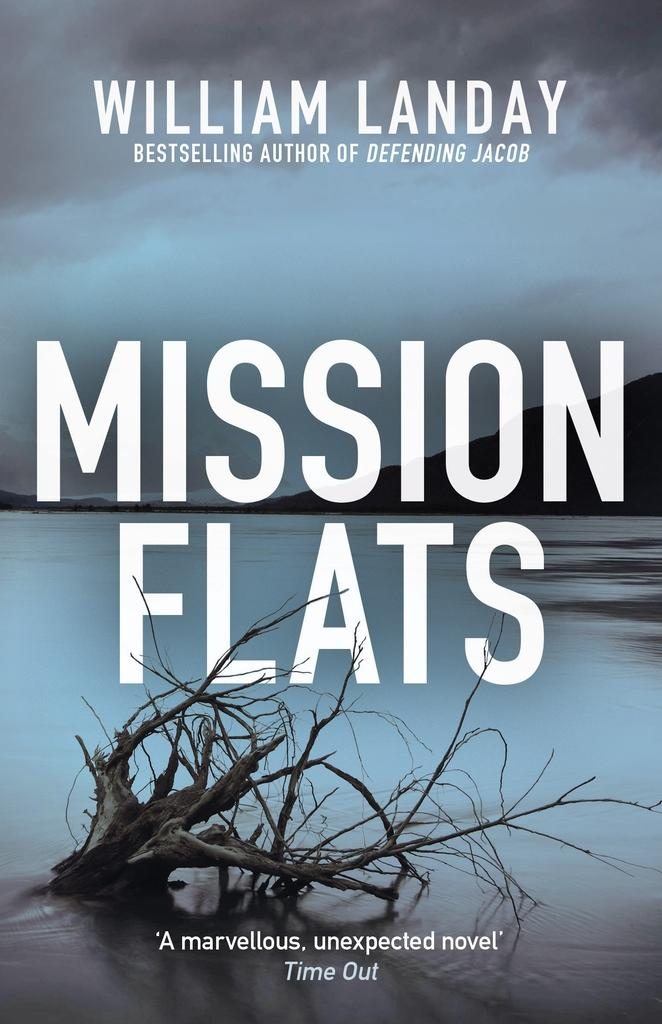<image>
Render a clear and concise summary of the photo. A book by William Landy has a large piece of driftwood on the cover. 